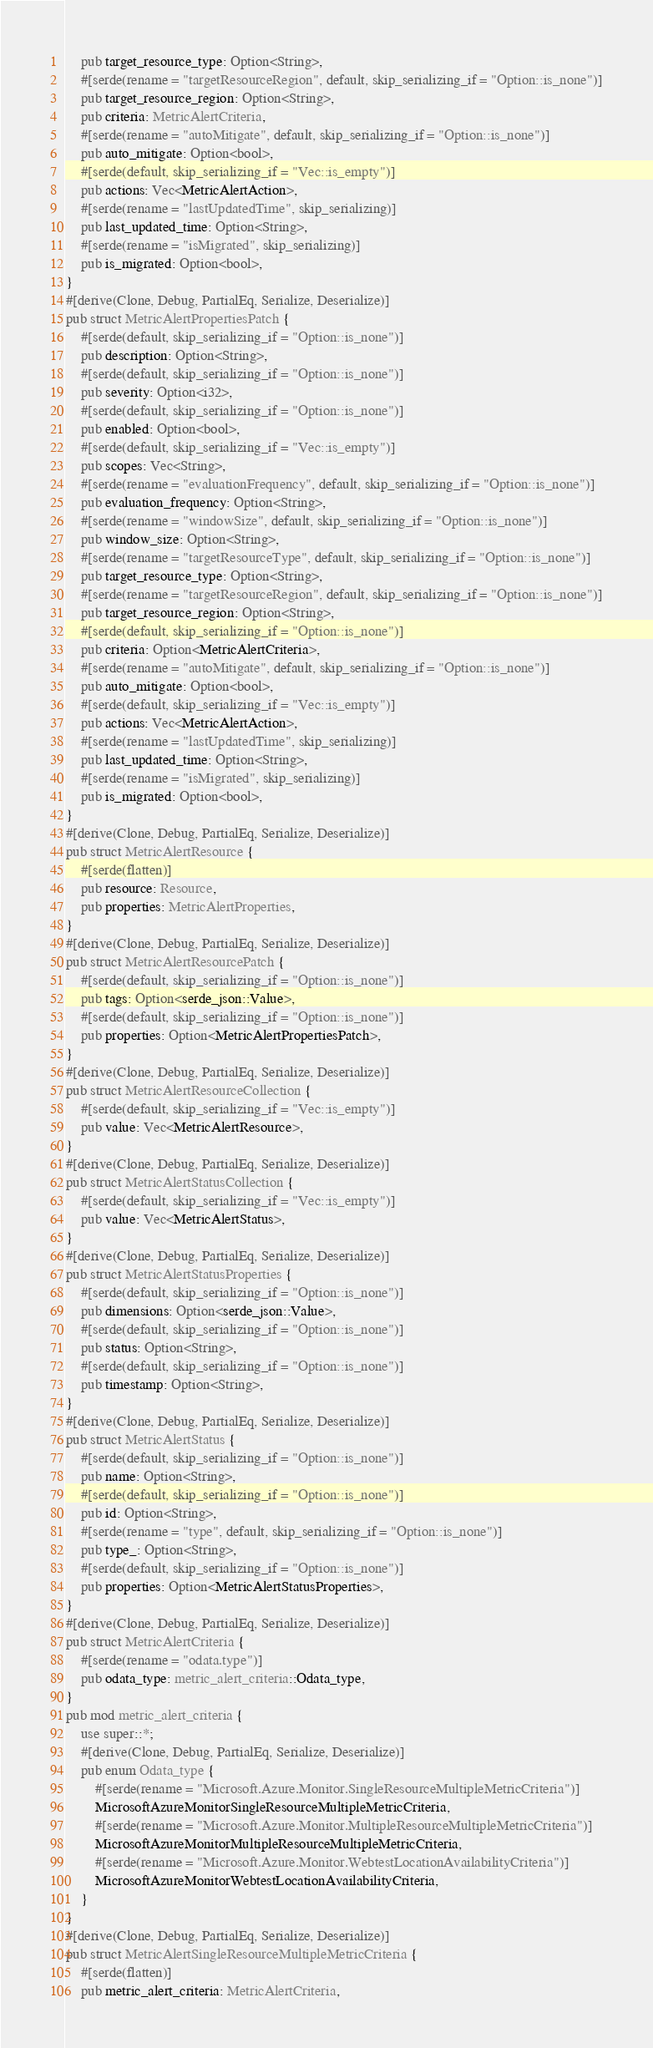Convert code to text. <code><loc_0><loc_0><loc_500><loc_500><_Rust_>    pub target_resource_type: Option<String>,
    #[serde(rename = "targetResourceRegion", default, skip_serializing_if = "Option::is_none")]
    pub target_resource_region: Option<String>,
    pub criteria: MetricAlertCriteria,
    #[serde(rename = "autoMitigate", default, skip_serializing_if = "Option::is_none")]
    pub auto_mitigate: Option<bool>,
    #[serde(default, skip_serializing_if = "Vec::is_empty")]
    pub actions: Vec<MetricAlertAction>,
    #[serde(rename = "lastUpdatedTime", skip_serializing)]
    pub last_updated_time: Option<String>,
    #[serde(rename = "isMigrated", skip_serializing)]
    pub is_migrated: Option<bool>,
}
#[derive(Clone, Debug, PartialEq, Serialize, Deserialize)]
pub struct MetricAlertPropertiesPatch {
    #[serde(default, skip_serializing_if = "Option::is_none")]
    pub description: Option<String>,
    #[serde(default, skip_serializing_if = "Option::is_none")]
    pub severity: Option<i32>,
    #[serde(default, skip_serializing_if = "Option::is_none")]
    pub enabled: Option<bool>,
    #[serde(default, skip_serializing_if = "Vec::is_empty")]
    pub scopes: Vec<String>,
    #[serde(rename = "evaluationFrequency", default, skip_serializing_if = "Option::is_none")]
    pub evaluation_frequency: Option<String>,
    #[serde(rename = "windowSize", default, skip_serializing_if = "Option::is_none")]
    pub window_size: Option<String>,
    #[serde(rename = "targetResourceType", default, skip_serializing_if = "Option::is_none")]
    pub target_resource_type: Option<String>,
    #[serde(rename = "targetResourceRegion", default, skip_serializing_if = "Option::is_none")]
    pub target_resource_region: Option<String>,
    #[serde(default, skip_serializing_if = "Option::is_none")]
    pub criteria: Option<MetricAlertCriteria>,
    #[serde(rename = "autoMitigate", default, skip_serializing_if = "Option::is_none")]
    pub auto_mitigate: Option<bool>,
    #[serde(default, skip_serializing_if = "Vec::is_empty")]
    pub actions: Vec<MetricAlertAction>,
    #[serde(rename = "lastUpdatedTime", skip_serializing)]
    pub last_updated_time: Option<String>,
    #[serde(rename = "isMigrated", skip_serializing)]
    pub is_migrated: Option<bool>,
}
#[derive(Clone, Debug, PartialEq, Serialize, Deserialize)]
pub struct MetricAlertResource {
    #[serde(flatten)]
    pub resource: Resource,
    pub properties: MetricAlertProperties,
}
#[derive(Clone, Debug, PartialEq, Serialize, Deserialize)]
pub struct MetricAlertResourcePatch {
    #[serde(default, skip_serializing_if = "Option::is_none")]
    pub tags: Option<serde_json::Value>,
    #[serde(default, skip_serializing_if = "Option::is_none")]
    pub properties: Option<MetricAlertPropertiesPatch>,
}
#[derive(Clone, Debug, PartialEq, Serialize, Deserialize)]
pub struct MetricAlertResourceCollection {
    #[serde(default, skip_serializing_if = "Vec::is_empty")]
    pub value: Vec<MetricAlertResource>,
}
#[derive(Clone, Debug, PartialEq, Serialize, Deserialize)]
pub struct MetricAlertStatusCollection {
    #[serde(default, skip_serializing_if = "Vec::is_empty")]
    pub value: Vec<MetricAlertStatus>,
}
#[derive(Clone, Debug, PartialEq, Serialize, Deserialize)]
pub struct MetricAlertStatusProperties {
    #[serde(default, skip_serializing_if = "Option::is_none")]
    pub dimensions: Option<serde_json::Value>,
    #[serde(default, skip_serializing_if = "Option::is_none")]
    pub status: Option<String>,
    #[serde(default, skip_serializing_if = "Option::is_none")]
    pub timestamp: Option<String>,
}
#[derive(Clone, Debug, PartialEq, Serialize, Deserialize)]
pub struct MetricAlertStatus {
    #[serde(default, skip_serializing_if = "Option::is_none")]
    pub name: Option<String>,
    #[serde(default, skip_serializing_if = "Option::is_none")]
    pub id: Option<String>,
    #[serde(rename = "type", default, skip_serializing_if = "Option::is_none")]
    pub type_: Option<String>,
    #[serde(default, skip_serializing_if = "Option::is_none")]
    pub properties: Option<MetricAlertStatusProperties>,
}
#[derive(Clone, Debug, PartialEq, Serialize, Deserialize)]
pub struct MetricAlertCriteria {
    #[serde(rename = "odata.type")]
    pub odata_type: metric_alert_criteria::Odata_type,
}
pub mod metric_alert_criteria {
    use super::*;
    #[derive(Clone, Debug, PartialEq, Serialize, Deserialize)]
    pub enum Odata_type {
        #[serde(rename = "Microsoft.Azure.Monitor.SingleResourceMultipleMetricCriteria")]
        MicrosoftAzureMonitorSingleResourceMultipleMetricCriteria,
        #[serde(rename = "Microsoft.Azure.Monitor.MultipleResourceMultipleMetricCriteria")]
        MicrosoftAzureMonitorMultipleResourceMultipleMetricCriteria,
        #[serde(rename = "Microsoft.Azure.Monitor.WebtestLocationAvailabilityCriteria")]
        MicrosoftAzureMonitorWebtestLocationAvailabilityCriteria,
    }
}
#[derive(Clone, Debug, PartialEq, Serialize, Deserialize)]
pub struct MetricAlertSingleResourceMultipleMetricCriteria {
    #[serde(flatten)]
    pub metric_alert_criteria: MetricAlertCriteria,</code> 